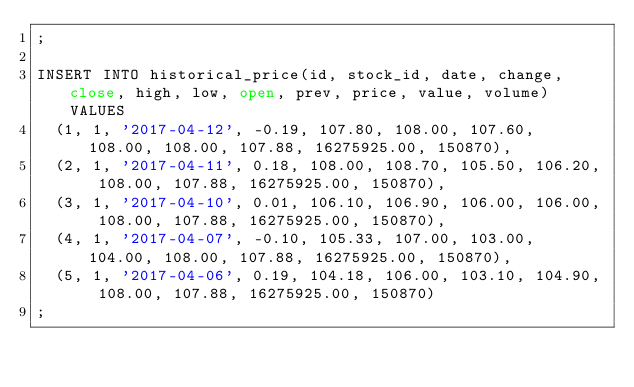Convert code to text. <code><loc_0><loc_0><loc_500><loc_500><_SQL_>;

INSERT INTO historical_price(id, stock_id, date, change, close, high, low, open, prev, price, value, volume) VALUES
  (1, 1, '2017-04-12', -0.19, 107.80, 108.00, 107.60, 108.00, 108.00, 107.88, 16275925.00, 150870),
  (2, 1, '2017-04-11', 0.18, 108.00, 108.70, 105.50, 106.20, 108.00, 107.88, 16275925.00, 150870),
  (3, 1, '2017-04-10', 0.01, 106.10, 106.90, 106.00, 106.00, 108.00, 107.88, 16275925.00, 150870),
  (4, 1, '2017-04-07', -0.10, 105.33, 107.00, 103.00, 104.00, 108.00, 107.88, 16275925.00, 150870),
  (5, 1, '2017-04-06', 0.19, 104.18, 106.00, 103.10, 104.90, 108.00, 107.88, 16275925.00, 150870)
;</code> 